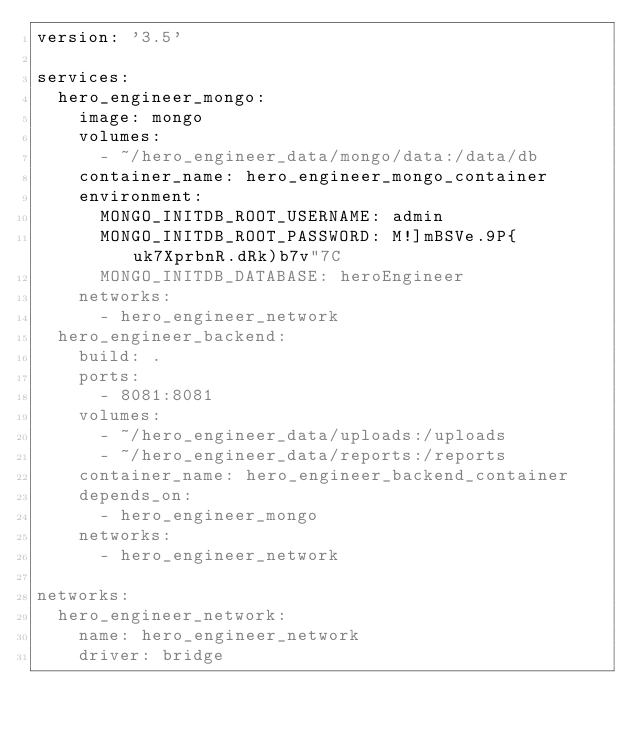Convert code to text. <code><loc_0><loc_0><loc_500><loc_500><_YAML_>version: '3.5'

services:
  hero_engineer_mongo:
    image: mongo
    volumes:
      - ~/hero_engineer_data/mongo/data:/data/db
    container_name: hero_engineer_mongo_container
    environment:
      MONGO_INITDB_ROOT_USERNAME: admin
      MONGO_INITDB_ROOT_PASSWORD: M!]mBSVe.9P{uk7XprbnR.dRk)b7v"7C
      MONGO_INITDB_DATABASE: heroEngineer
    networks:
      - hero_engineer_network
  hero_engineer_backend:
    build: .
    ports:
      - 8081:8081
    volumes:
      - ~/hero_engineer_data/uploads:/uploads
      - ~/hero_engineer_data/reports:/reports
    container_name: hero_engineer_backend_container
    depends_on:
      - hero_engineer_mongo
    networks:
      - hero_engineer_network

networks:
  hero_engineer_network:
    name: hero_engineer_network
    driver: bridge
</code> 